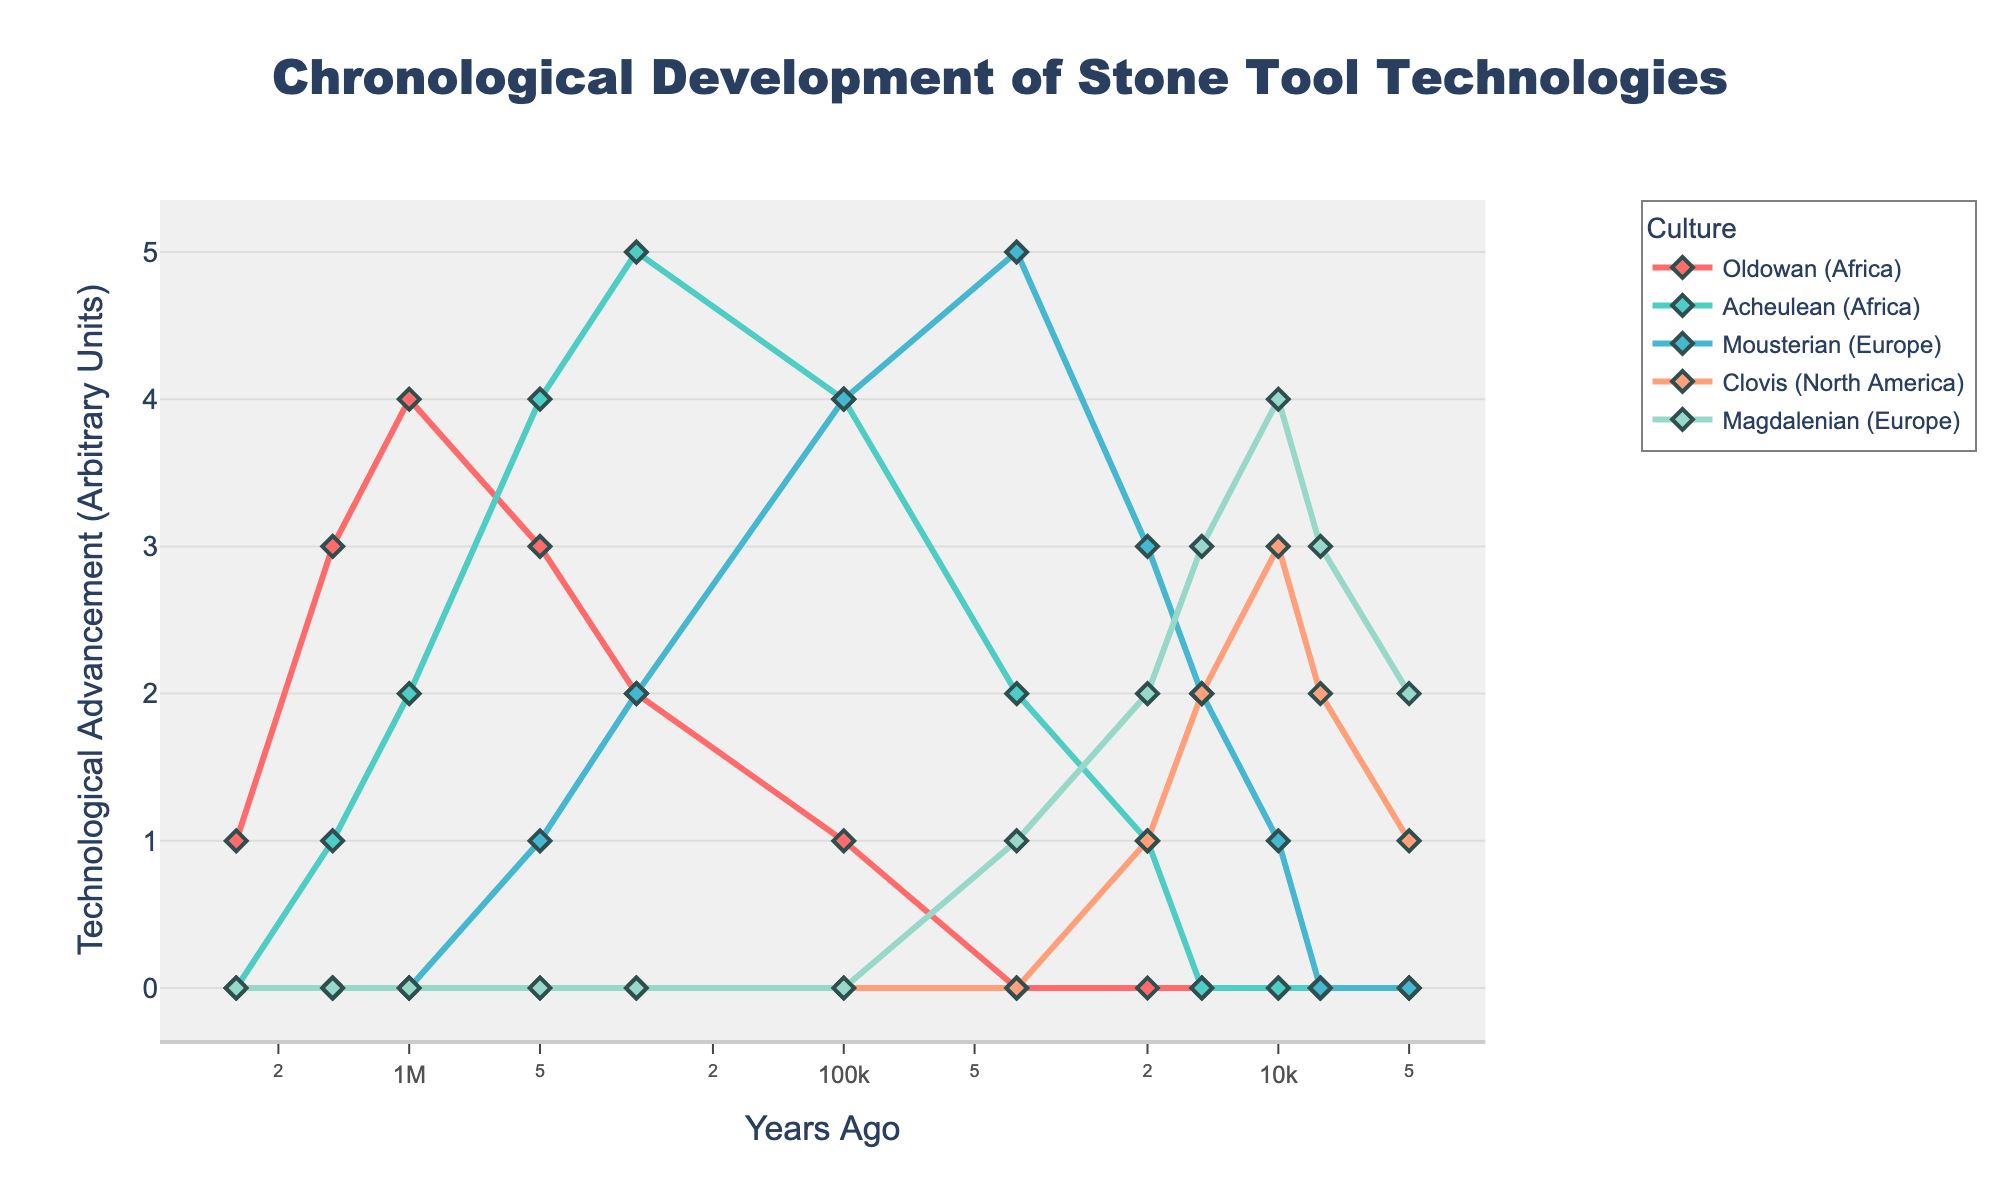What's the latest time period when Oldowan technology is represented? Look at the chart for the lowest time period where Oldowan (red line) is still above zero. The Oldowan line has a value above zero until the 100,000 years ago mark. After that, it no longer appears.
Answer: 100,000 years ago Which culture shows a continuous presence throughout the entire timeline? Examine the chart for any culture represented from the earliest to the latest time period. Acheulean (green line) is present from 2,500,000 years ago to 5,000 years ago continuously.
Answer: Acheulean What is the highest technological advancement unit achieved by the Mousterian culture? Identify the peak value on the y-axis for the Mousterian (blue line). The blue line reaches its highest point at the 40,000 years ago mark with a value of 5.
Answer: 5 How does the advancement of the Clovis culture compare to the Magdalenian culture around 10,000 years ago? Compare the values of the Clovis (orange line) and Magdalenian (purple line) just above the 10,000 years ago mark. Clovis has a value of 3, while Magdalenian has a value of 4 at this time period.
Answer: Clovis: 3, Magdalenian: 4 Which two cultures are represented during the time period of 20,000 years ago? Scan the chart at the 20,000 years ago mark to see which lines have non-zero values. Both Clovis (orange) and Magdalenian (purple) lines are above zero at this time.
Answer: Clovis and Magdalenian What is the total technological advancement of the Oldowan culture over time? Sum the values representing Oldowan (red line) across all time periods. 1 + 3 + 4 + 3 + 2 + 1 = 14.
Answer: 14 Which culture appears the latest in the timeline? Find the culture that first appears at the most recent time period. The Clovis (orange line) first appears at 20,000 years ago.
Answer: Clovis Quantify the change in technological advancement for Acheulean culture between 1,500,000 and 100,000 years ago. Determine the values of Acheulean (green line) at these points: 1 at 1,500,000 years ago, and 4 at 100,000 years ago. The change is 4 - 1 = 3 units.
Answer: 3 units How many cultures are represented before 100,000 years ago? Count the different cultures with non-zero values on the chart before the 100,000 years ago mark. Oldowan, Acheulean, and Mousterian are represented.
Answer: 3 At which time period did Magdalenian culture reach its peak and what was the value? Identify the highest point on the Magdalenian (purple) line. The highest value of 4 is reached at the 10,000 years ago mark.
Answer: 10,000 years ago, 4 